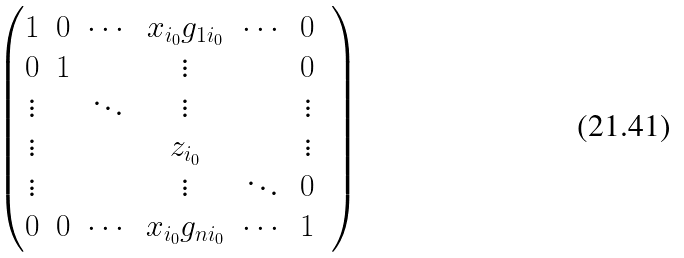Convert formula to latex. <formula><loc_0><loc_0><loc_500><loc_500>\begin{pmatrix} 1 & 0 & \cdots & x _ { i _ { 0 } } g _ { 1 i _ { 0 } } & \cdots & 0 & \\ 0 & 1 & & \vdots & & 0 & \\ \vdots & & \ddots & \vdots & & \vdots & \\ \vdots & & & z _ { i _ { 0 } } & & \vdots & \\ \vdots & & & \vdots & \ddots & 0 & \\ 0 & 0 & \cdots & x _ { i _ { 0 } } g _ { n i _ { 0 } } & \cdots & 1 & \end{pmatrix}</formula> 